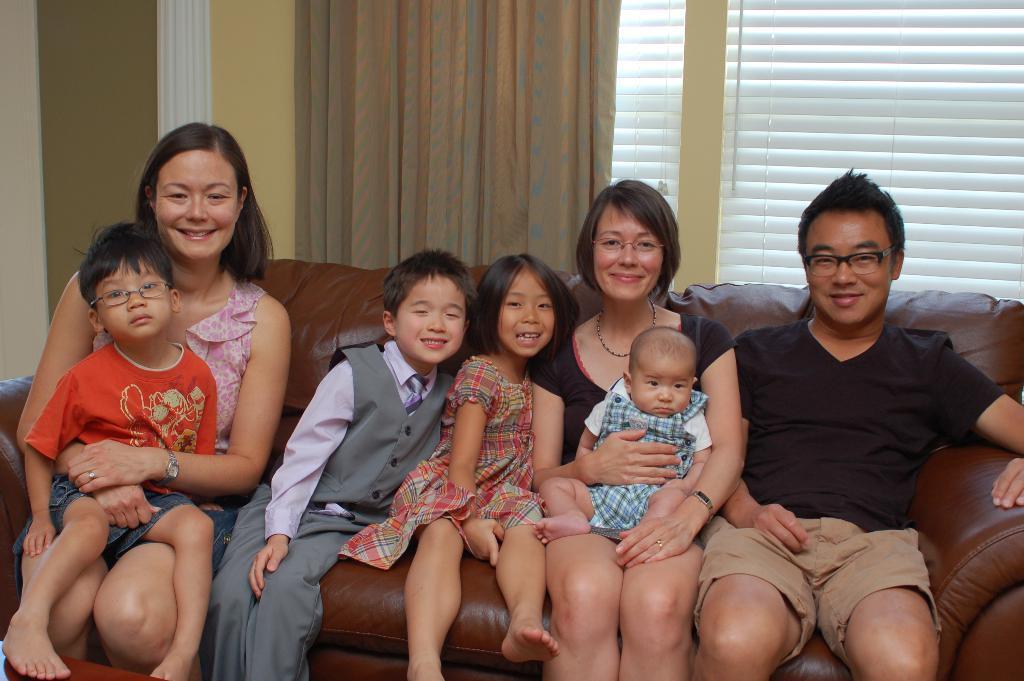Can you describe this image briefly? In this picture I can see there are two women and a man sitting on the couch and in the backdrop there is a window and a curtain. The man and woman at right are wearing spectacles and there is a boy at left and he is also wearing spectacles. 